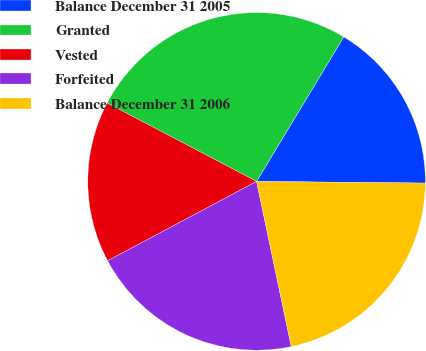Convert chart to OTSL. <chart><loc_0><loc_0><loc_500><loc_500><pie_chart><fcel>Balance December 31 2005<fcel>Granted<fcel>Vested<fcel>Forfeited<fcel>Balance December 31 2006<nl><fcel>16.52%<fcel>25.95%<fcel>15.48%<fcel>20.5%<fcel>21.55%<nl></chart> 